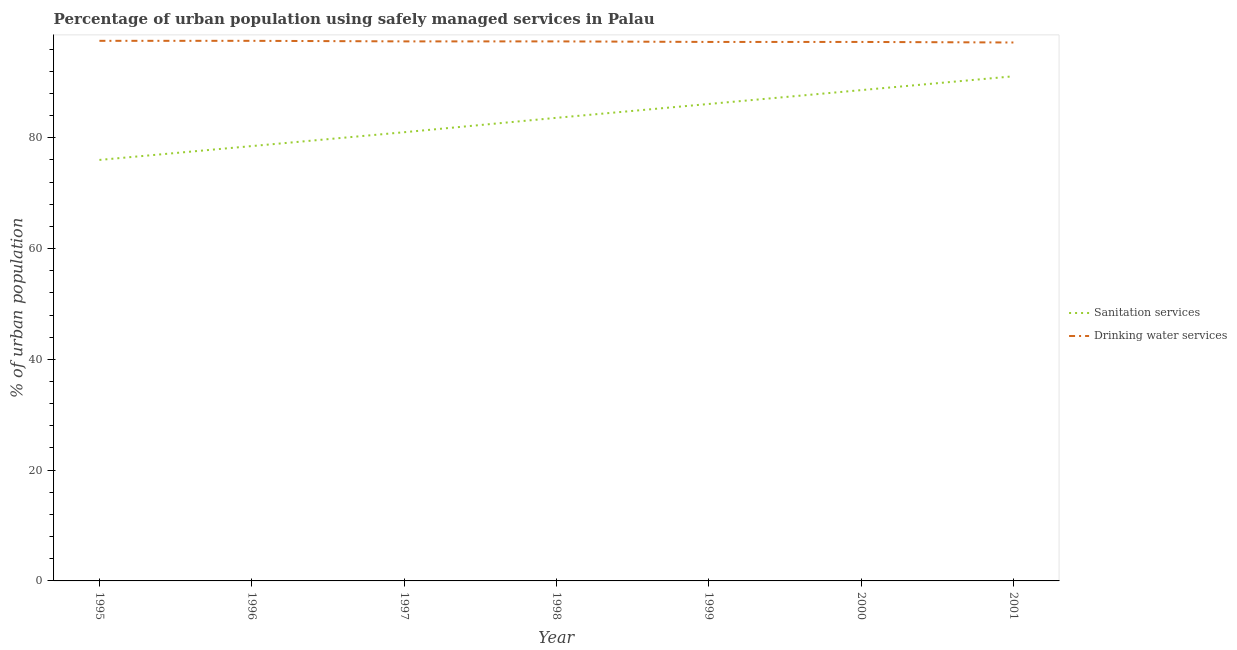How many different coloured lines are there?
Make the answer very short. 2. Does the line corresponding to percentage of urban population who used drinking water services intersect with the line corresponding to percentage of urban population who used sanitation services?
Ensure brevity in your answer.  No. Is the number of lines equal to the number of legend labels?
Your answer should be very brief. Yes. What is the percentage of urban population who used sanitation services in 1999?
Provide a succinct answer. 86.1. Across all years, what is the maximum percentage of urban population who used sanitation services?
Offer a very short reply. 91.1. Across all years, what is the minimum percentage of urban population who used drinking water services?
Your response must be concise. 97.2. In which year was the percentage of urban population who used drinking water services maximum?
Keep it short and to the point. 1995. What is the total percentage of urban population who used drinking water services in the graph?
Your answer should be very brief. 681.6. What is the difference between the percentage of urban population who used sanitation services in 1996 and that in 1997?
Ensure brevity in your answer.  -2.5. What is the difference between the percentage of urban population who used drinking water services in 1998 and the percentage of urban population who used sanitation services in 1997?
Give a very brief answer. 16.4. What is the average percentage of urban population who used sanitation services per year?
Ensure brevity in your answer.  83.56. In the year 2001, what is the difference between the percentage of urban population who used sanitation services and percentage of urban population who used drinking water services?
Ensure brevity in your answer.  -6.1. In how many years, is the percentage of urban population who used sanitation services greater than 64 %?
Make the answer very short. 7. What is the ratio of the percentage of urban population who used drinking water services in 1995 to that in 2001?
Provide a succinct answer. 1. Is the percentage of urban population who used sanitation services in 1995 less than that in 2001?
Give a very brief answer. Yes. What is the difference between the highest and the second highest percentage of urban population who used sanitation services?
Give a very brief answer. 2.5. What is the difference between the highest and the lowest percentage of urban population who used drinking water services?
Offer a very short reply. 0.3. Is the sum of the percentage of urban population who used sanitation services in 1995 and 2000 greater than the maximum percentage of urban population who used drinking water services across all years?
Keep it short and to the point. Yes. Does the percentage of urban population who used sanitation services monotonically increase over the years?
Provide a short and direct response. Yes. Is the percentage of urban population who used drinking water services strictly less than the percentage of urban population who used sanitation services over the years?
Provide a short and direct response. No. What is the difference between two consecutive major ticks on the Y-axis?
Offer a very short reply. 20. Are the values on the major ticks of Y-axis written in scientific E-notation?
Provide a short and direct response. No. Where does the legend appear in the graph?
Give a very brief answer. Center right. How are the legend labels stacked?
Your response must be concise. Vertical. What is the title of the graph?
Provide a succinct answer. Percentage of urban population using safely managed services in Palau. Does "Death rate" appear as one of the legend labels in the graph?
Your response must be concise. No. What is the label or title of the X-axis?
Ensure brevity in your answer.  Year. What is the label or title of the Y-axis?
Provide a short and direct response. % of urban population. What is the % of urban population of Sanitation services in 1995?
Offer a very short reply. 76. What is the % of urban population of Drinking water services in 1995?
Your answer should be very brief. 97.5. What is the % of urban population of Sanitation services in 1996?
Your answer should be compact. 78.5. What is the % of urban population of Drinking water services in 1996?
Your answer should be compact. 97.5. What is the % of urban population of Drinking water services in 1997?
Your response must be concise. 97.4. What is the % of urban population in Sanitation services in 1998?
Provide a succinct answer. 83.6. What is the % of urban population in Drinking water services in 1998?
Give a very brief answer. 97.4. What is the % of urban population of Sanitation services in 1999?
Provide a short and direct response. 86.1. What is the % of urban population in Drinking water services in 1999?
Give a very brief answer. 97.3. What is the % of urban population in Sanitation services in 2000?
Keep it short and to the point. 88.6. What is the % of urban population in Drinking water services in 2000?
Make the answer very short. 97.3. What is the % of urban population in Sanitation services in 2001?
Ensure brevity in your answer.  91.1. What is the % of urban population of Drinking water services in 2001?
Give a very brief answer. 97.2. Across all years, what is the maximum % of urban population in Sanitation services?
Your answer should be very brief. 91.1. Across all years, what is the maximum % of urban population of Drinking water services?
Make the answer very short. 97.5. Across all years, what is the minimum % of urban population of Sanitation services?
Make the answer very short. 76. Across all years, what is the minimum % of urban population of Drinking water services?
Provide a succinct answer. 97.2. What is the total % of urban population in Sanitation services in the graph?
Give a very brief answer. 584.9. What is the total % of urban population of Drinking water services in the graph?
Provide a short and direct response. 681.6. What is the difference between the % of urban population of Sanitation services in 1995 and that in 1996?
Make the answer very short. -2.5. What is the difference between the % of urban population in Drinking water services in 1995 and that in 1996?
Your response must be concise. 0. What is the difference between the % of urban population of Drinking water services in 1995 and that in 1999?
Make the answer very short. 0.2. What is the difference between the % of urban population in Drinking water services in 1995 and that in 2000?
Provide a short and direct response. 0.2. What is the difference between the % of urban population in Sanitation services in 1995 and that in 2001?
Offer a terse response. -15.1. What is the difference between the % of urban population in Drinking water services in 1995 and that in 2001?
Ensure brevity in your answer.  0.3. What is the difference between the % of urban population of Sanitation services in 1996 and that in 1999?
Your response must be concise. -7.6. What is the difference between the % of urban population in Sanitation services in 1996 and that in 2001?
Offer a terse response. -12.6. What is the difference between the % of urban population of Sanitation services in 1997 and that in 1998?
Your answer should be very brief. -2.6. What is the difference between the % of urban population of Drinking water services in 1997 and that in 1998?
Your answer should be very brief. 0. What is the difference between the % of urban population of Drinking water services in 1997 and that in 1999?
Your answer should be very brief. 0.1. What is the difference between the % of urban population in Sanitation services in 1997 and that in 2001?
Provide a succinct answer. -10.1. What is the difference between the % of urban population in Drinking water services in 1998 and that in 1999?
Provide a short and direct response. 0.1. What is the difference between the % of urban population of Sanitation services in 1998 and that in 2001?
Your response must be concise. -7.5. What is the difference between the % of urban population in Drinking water services in 1998 and that in 2001?
Provide a succinct answer. 0.2. What is the difference between the % of urban population in Sanitation services in 1999 and that in 2000?
Offer a very short reply. -2.5. What is the difference between the % of urban population of Drinking water services in 1999 and that in 2000?
Your answer should be very brief. 0. What is the difference between the % of urban population in Sanitation services in 1999 and that in 2001?
Your answer should be compact. -5. What is the difference between the % of urban population in Drinking water services in 2000 and that in 2001?
Ensure brevity in your answer.  0.1. What is the difference between the % of urban population in Sanitation services in 1995 and the % of urban population in Drinking water services in 1996?
Your response must be concise. -21.5. What is the difference between the % of urban population of Sanitation services in 1995 and the % of urban population of Drinking water services in 1997?
Provide a short and direct response. -21.4. What is the difference between the % of urban population of Sanitation services in 1995 and the % of urban population of Drinking water services in 1998?
Your response must be concise. -21.4. What is the difference between the % of urban population in Sanitation services in 1995 and the % of urban population in Drinking water services in 1999?
Provide a succinct answer. -21.3. What is the difference between the % of urban population in Sanitation services in 1995 and the % of urban population in Drinking water services in 2000?
Offer a terse response. -21.3. What is the difference between the % of urban population of Sanitation services in 1995 and the % of urban population of Drinking water services in 2001?
Offer a terse response. -21.2. What is the difference between the % of urban population of Sanitation services in 1996 and the % of urban population of Drinking water services in 1997?
Keep it short and to the point. -18.9. What is the difference between the % of urban population of Sanitation services in 1996 and the % of urban population of Drinking water services in 1998?
Ensure brevity in your answer.  -18.9. What is the difference between the % of urban population of Sanitation services in 1996 and the % of urban population of Drinking water services in 1999?
Your answer should be compact. -18.8. What is the difference between the % of urban population of Sanitation services in 1996 and the % of urban population of Drinking water services in 2000?
Provide a succinct answer. -18.8. What is the difference between the % of urban population in Sanitation services in 1996 and the % of urban population in Drinking water services in 2001?
Offer a very short reply. -18.7. What is the difference between the % of urban population in Sanitation services in 1997 and the % of urban population in Drinking water services in 1998?
Your response must be concise. -16.4. What is the difference between the % of urban population in Sanitation services in 1997 and the % of urban population in Drinking water services in 1999?
Your answer should be compact. -16.3. What is the difference between the % of urban population of Sanitation services in 1997 and the % of urban population of Drinking water services in 2000?
Ensure brevity in your answer.  -16.3. What is the difference between the % of urban population in Sanitation services in 1997 and the % of urban population in Drinking water services in 2001?
Your answer should be compact. -16.2. What is the difference between the % of urban population of Sanitation services in 1998 and the % of urban population of Drinking water services in 1999?
Give a very brief answer. -13.7. What is the difference between the % of urban population of Sanitation services in 1998 and the % of urban population of Drinking water services in 2000?
Provide a short and direct response. -13.7. What is the difference between the % of urban population of Sanitation services in 2000 and the % of urban population of Drinking water services in 2001?
Provide a short and direct response. -8.6. What is the average % of urban population in Sanitation services per year?
Provide a short and direct response. 83.56. What is the average % of urban population of Drinking water services per year?
Keep it short and to the point. 97.37. In the year 1995, what is the difference between the % of urban population in Sanitation services and % of urban population in Drinking water services?
Provide a succinct answer. -21.5. In the year 1997, what is the difference between the % of urban population in Sanitation services and % of urban population in Drinking water services?
Ensure brevity in your answer.  -16.4. In the year 1999, what is the difference between the % of urban population in Sanitation services and % of urban population in Drinking water services?
Give a very brief answer. -11.2. In the year 2000, what is the difference between the % of urban population of Sanitation services and % of urban population of Drinking water services?
Offer a terse response. -8.7. What is the ratio of the % of urban population of Sanitation services in 1995 to that in 1996?
Offer a terse response. 0.97. What is the ratio of the % of urban population in Sanitation services in 1995 to that in 1997?
Your answer should be very brief. 0.94. What is the ratio of the % of urban population of Sanitation services in 1995 to that in 1999?
Make the answer very short. 0.88. What is the ratio of the % of urban population in Sanitation services in 1995 to that in 2000?
Ensure brevity in your answer.  0.86. What is the ratio of the % of urban population in Sanitation services in 1995 to that in 2001?
Your answer should be very brief. 0.83. What is the ratio of the % of urban population of Sanitation services in 1996 to that in 1997?
Make the answer very short. 0.97. What is the ratio of the % of urban population of Sanitation services in 1996 to that in 1998?
Offer a very short reply. 0.94. What is the ratio of the % of urban population in Drinking water services in 1996 to that in 1998?
Provide a succinct answer. 1. What is the ratio of the % of urban population in Sanitation services in 1996 to that in 1999?
Keep it short and to the point. 0.91. What is the ratio of the % of urban population of Drinking water services in 1996 to that in 1999?
Your answer should be compact. 1. What is the ratio of the % of urban population in Sanitation services in 1996 to that in 2000?
Your answer should be very brief. 0.89. What is the ratio of the % of urban population in Drinking water services in 1996 to that in 2000?
Offer a very short reply. 1. What is the ratio of the % of urban population of Sanitation services in 1996 to that in 2001?
Make the answer very short. 0.86. What is the ratio of the % of urban population in Sanitation services in 1997 to that in 1998?
Ensure brevity in your answer.  0.97. What is the ratio of the % of urban population in Drinking water services in 1997 to that in 1998?
Keep it short and to the point. 1. What is the ratio of the % of urban population of Sanitation services in 1997 to that in 1999?
Your answer should be very brief. 0.94. What is the ratio of the % of urban population in Drinking water services in 1997 to that in 1999?
Provide a short and direct response. 1. What is the ratio of the % of urban population of Sanitation services in 1997 to that in 2000?
Offer a terse response. 0.91. What is the ratio of the % of urban population of Sanitation services in 1997 to that in 2001?
Make the answer very short. 0.89. What is the ratio of the % of urban population in Sanitation services in 1998 to that in 1999?
Offer a terse response. 0.97. What is the ratio of the % of urban population in Sanitation services in 1998 to that in 2000?
Make the answer very short. 0.94. What is the ratio of the % of urban population of Sanitation services in 1998 to that in 2001?
Your answer should be compact. 0.92. What is the ratio of the % of urban population of Drinking water services in 1998 to that in 2001?
Make the answer very short. 1. What is the ratio of the % of urban population in Sanitation services in 1999 to that in 2000?
Provide a short and direct response. 0.97. What is the ratio of the % of urban population in Sanitation services in 1999 to that in 2001?
Provide a short and direct response. 0.95. What is the ratio of the % of urban population of Sanitation services in 2000 to that in 2001?
Keep it short and to the point. 0.97. What is the ratio of the % of urban population of Drinking water services in 2000 to that in 2001?
Provide a succinct answer. 1. What is the difference between the highest and the second highest % of urban population in Sanitation services?
Your answer should be very brief. 2.5. What is the difference between the highest and the second highest % of urban population of Drinking water services?
Your response must be concise. 0. 